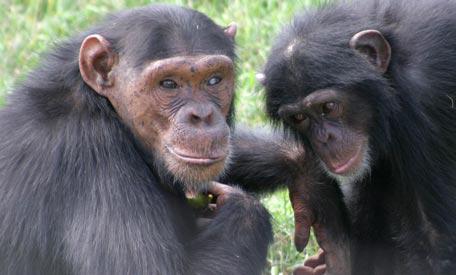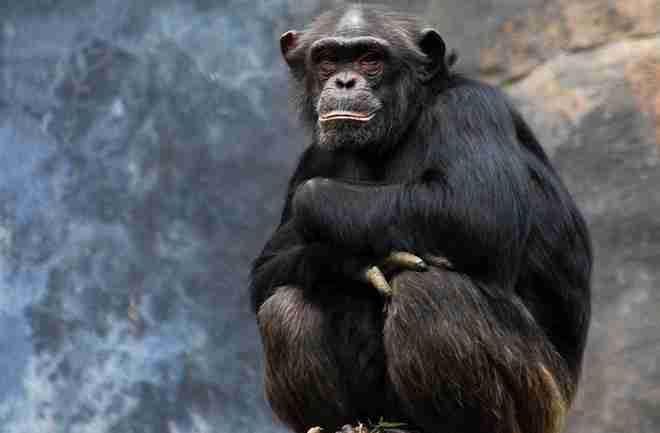The first image is the image on the left, the second image is the image on the right. Given the left and right images, does the statement "There are fewer than five chimpanzees in total." hold true? Answer yes or no. Yes. The first image is the image on the left, the second image is the image on the right. Evaluate the accuracy of this statement regarding the images: "Each image includes a baby ape in front of an adult ape.". Is it true? Answer yes or no. No. 